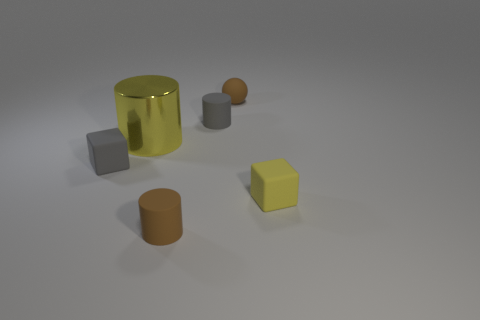Subtract all red blocks. Subtract all blue balls. How many blocks are left? 2 Add 3 tiny matte spheres. How many objects exist? 9 Subtract all blocks. How many objects are left? 4 Add 2 tiny yellow matte objects. How many tiny yellow matte objects exist? 3 Subtract 0 cyan spheres. How many objects are left? 6 Subtract all large yellow things. Subtract all large cyan matte objects. How many objects are left? 5 Add 3 tiny blocks. How many tiny blocks are left? 5 